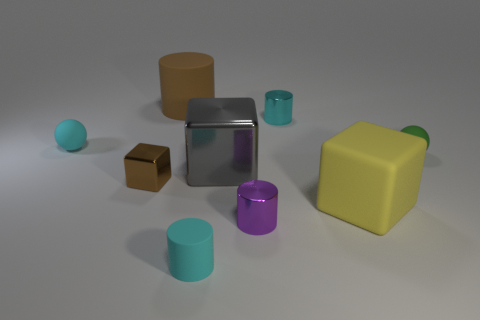What shape is the tiny brown metallic object?
Your answer should be compact. Cube. Is there a brown object to the left of the rubber cylinder behind the small sphere that is on the left side of the small cyan rubber cylinder?
Your answer should be very brief. Yes. What is the color of the big thing behind the tiny matte sphere in front of the tiny sphere that is on the left side of the small brown metal block?
Provide a short and direct response. Brown. There is a tiny purple thing that is the same shape as the large brown rubber object; what is it made of?
Your answer should be compact. Metal. How big is the rubber thing that is behind the cyan thing that is on the left side of the small metal cube?
Your response must be concise. Large. There is a purple cylinder that is in front of the big rubber cylinder; what is its material?
Make the answer very short. Metal. The brown thing that is made of the same material as the small purple object is what size?
Your response must be concise. Small. What number of small purple metal things have the same shape as the gray metallic thing?
Offer a very short reply. 0. Do the big brown rubber object and the gray metallic object on the left side of the yellow block have the same shape?
Make the answer very short. No. The tiny shiny object that is the same color as the big cylinder is what shape?
Your answer should be very brief. Cube. 